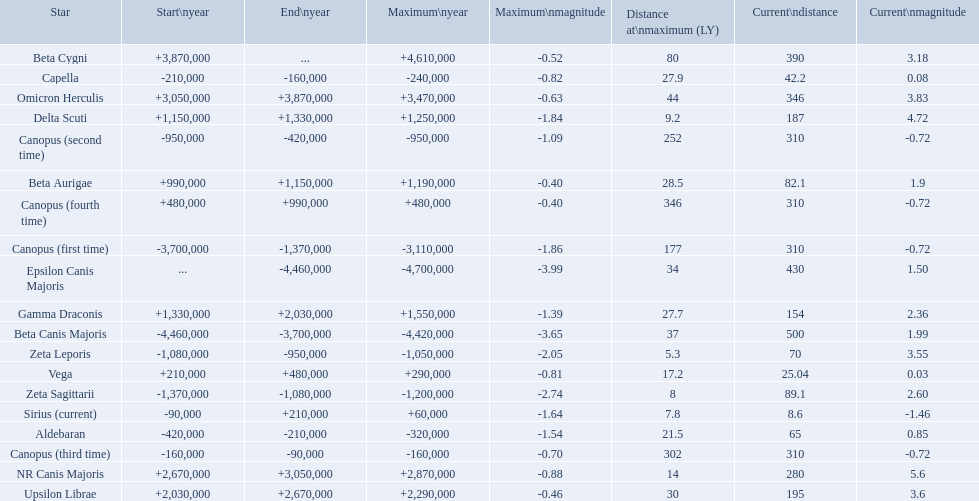What are all the stars? Epsilon Canis Majoris, Beta Canis Majoris, Canopus (first time), Zeta Sagittarii, Zeta Leporis, Canopus (second time), Aldebaran, Capella, Canopus (third time), Sirius (current), Vega, Canopus (fourth time), Beta Aurigae, Delta Scuti, Gamma Draconis, Upsilon Librae, NR Canis Majoris, Omicron Herculis, Beta Cygni. Of those, which star has a maximum distance of 80? Beta Cygni. 